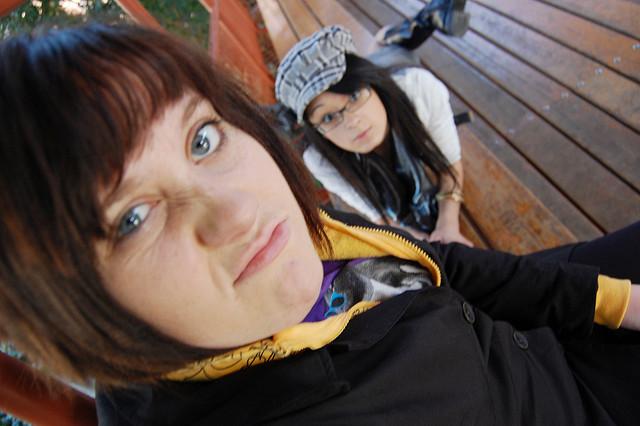What is on the girls head?
Answer briefly. Hat. What expression is on the woman's face?
Write a very short answer. Grumpy. What is the kid holding?
Answer briefly. Nothing. Does the girl look serious?
Quick response, please. Yes. Who is taking the photo?
Concise answer only. Woman. 